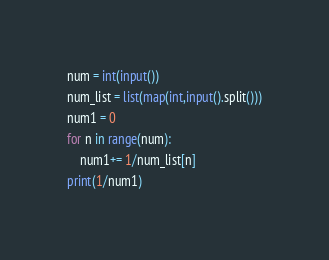Convert code to text. <code><loc_0><loc_0><loc_500><loc_500><_Python_>num = int(input())
num_list = list(map(int,input().split()))
num1 = 0
for n in range(num):
    num1+= 1/num_list[n]
print(1/num1)</code> 